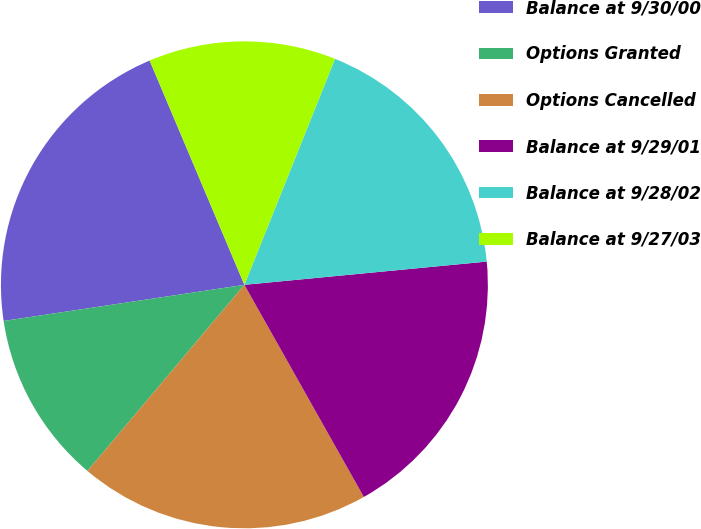<chart> <loc_0><loc_0><loc_500><loc_500><pie_chart><fcel>Balance at 9/30/00<fcel>Options Granted<fcel>Options Cancelled<fcel>Balance at 9/29/01<fcel>Balance at 9/28/02<fcel>Balance at 9/27/03<nl><fcel>21.01%<fcel>11.48%<fcel>19.31%<fcel>18.36%<fcel>17.41%<fcel>12.43%<nl></chart> 